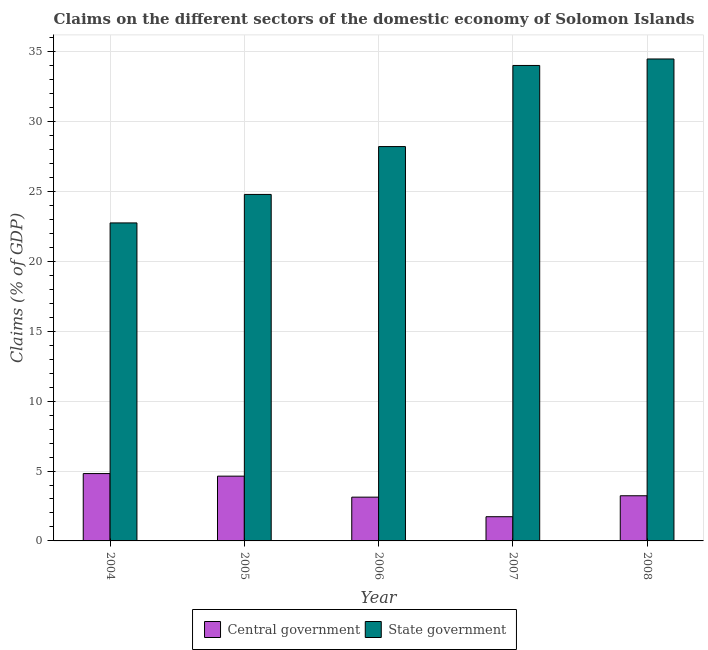Are the number of bars per tick equal to the number of legend labels?
Your answer should be compact. Yes. How many bars are there on the 5th tick from the right?
Ensure brevity in your answer.  2. What is the label of the 3rd group of bars from the left?
Offer a very short reply. 2006. What is the claims on central government in 2004?
Your answer should be compact. 4.82. Across all years, what is the maximum claims on state government?
Your answer should be compact. 34.48. Across all years, what is the minimum claims on central government?
Your response must be concise. 1.73. In which year was the claims on state government maximum?
Your response must be concise. 2008. In which year was the claims on central government minimum?
Offer a terse response. 2007. What is the total claims on central government in the graph?
Your response must be concise. 17.54. What is the difference between the claims on state government in 2006 and that in 2007?
Keep it short and to the point. -5.8. What is the difference between the claims on state government in 2005 and the claims on central government in 2004?
Provide a short and direct response. 2.04. What is the average claims on central government per year?
Offer a terse response. 3.51. In the year 2005, what is the difference between the claims on central government and claims on state government?
Give a very brief answer. 0. In how many years, is the claims on state government greater than 23 %?
Offer a terse response. 4. What is the ratio of the claims on state government in 2004 to that in 2005?
Make the answer very short. 0.92. What is the difference between the highest and the second highest claims on state government?
Ensure brevity in your answer.  0.46. What is the difference between the highest and the lowest claims on state government?
Your response must be concise. 11.73. What does the 2nd bar from the left in 2008 represents?
Keep it short and to the point. State government. What does the 2nd bar from the right in 2008 represents?
Make the answer very short. Central government. What is the difference between two consecutive major ticks on the Y-axis?
Your response must be concise. 5. Are the values on the major ticks of Y-axis written in scientific E-notation?
Your answer should be very brief. No. Does the graph contain grids?
Your answer should be compact. Yes. Where does the legend appear in the graph?
Give a very brief answer. Bottom center. How many legend labels are there?
Provide a succinct answer. 2. How are the legend labels stacked?
Provide a succinct answer. Horizontal. What is the title of the graph?
Your response must be concise. Claims on the different sectors of the domestic economy of Solomon Islands. Does "Nitrous oxide" appear as one of the legend labels in the graph?
Give a very brief answer. No. What is the label or title of the X-axis?
Your answer should be compact. Year. What is the label or title of the Y-axis?
Your answer should be compact. Claims (% of GDP). What is the Claims (% of GDP) of Central government in 2004?
Offer a terse response. 4.82. What is the Claims (% of GDP) of State government in 2004?
Give a very brief answer. 22.75. What is the Claims (% of GDP) of Central government in 2005?
Keep it short and to the point. 4.63. What is the Claims (% of GDP) in State government in 2005?
Your answer should be compact. 24.79. What is the Claims (% of GDP) in Central government in 2006?
Ensure brevity in your answer.  3.13. What is the Claims (% of GDP) in State government in 2006?
Keep it short and to the point. 28.21. What is the Claims (% of GDP) in Central government in 2007?
Your response must be concise. 1.73. What is the Claims (% of GDP) in State government in 2007?
Ensure brevity in your answer.  34.01. What is the Claims (% of GDP) of Central government in 2008?
Your answer should be compact. 3.23. What is the Claims (% of GDP) of State government in 2008?
Your answer should be compact. 34.48. Across all years, what is the maximum Claims (% of GDP) in Central government?
Offer a terse response. 4.82. Across all years, what is the maximum Claims (% of GDP) in State government?
Your answer should be compact. 34.48. Across all years, what is the minimum Claims (% of GDP) in Central government?
Provide a succinct answer. 1.73. Across all years, what is the minimum Claims (% of GDP) in State government?
Keep it short and to the point. 22.75. What is the total Claims (% of GDP) of Central government in the graph?
Your answer should be very brief. 17.54. What is the total Claims (% of GDP) of State government in the graph?
Ensure brevity in your answer.  144.24. What is the difference between the Claims (% of GDP) of Central government in 2004 and that in 2005?
Your response must be concise. 0.18. What is the difference between the Claims (% of GDP) in State government in 2004 and that in 2005?
Offer a very short reply. -2.04. What is the difference between the Claims (% of GDP) of Central government in 2004 and that in 2006?
Offer a terse response. 1.69. What is the difference between the Claims (% of GDP) in State government in 2004 and that in 2006?
Your answer should be compact. -5.46. What is the difference between the Claims (% of GDP) of Central government in 2004 and that in 2007?
Offer a terse response. 3.09. What is the difference between the Claims (% of GDP) in State government in 2004 and that in 2007?
Provide a short and direct response. -11.26. What is the difference between the Claims (% of GDP) of Central government in 2004 and that in 2008?
Provide a succinct answer. 1.59. What is the difference between the Claims (% of GDP) in State government in 2004 and that in 2008?
Your response must be concise. -11.73. What is the difference between the Claims (% of GDP) in Central government in 2005 and that in 2006?
Make the answer very short. 1.5. What is the difference between the Claims (% of GDP) of State government in 2005 and that in 2006?
Offer a terse response. -3.42. What is the difference between the Claims (% of GDP) in Central government in 2005 and that in 2007?
Ensure brevity in your answer.  2.9. What is the difference between the Claims (% of GDP) in State government in 2005 and that in 2007?
Your answer should be compact. -9.23. What is the difference between the Claims (% of GDP) in Central government in 2005 and that in 2008?
Provide a short and direct response. 1.4. What is the difference between the Claims (% of GDP) in State government in 2005 and that in 2008?
Provide a short and direct response. -9.69. What is the difference between the Claims (% of GDP) of Central government in 2006 and that in 2007?
Ensure brevity in your answer.  1.4. What is the difference between the Claims (% of GDP) of State government in 2006 and that in 2007?
Offer a very short reply. -5.8. What is the difference between the Claims (% of GDP) of Central government in 2006 and that in 2008?
Give a very brief answer. -0.1. What is the difference between the Claims (% of GDP) of State government in 2006 and that in 2008?
Offer a very short reply. -6.27. What is the difference between the Claims (% of GDP) in Central government in 2007 and that in 2008?
Provide a succinct answer. -1.5. What is the difference between the Claims (% of GDP) of State government in 2007 and that in 2008?
Your answer should be very brief. -0.46. What is the difference between the Claims (% of GDP) of Central government in 2004 and the Claims (% of GDP) of State government in 2005?
Offer a very short reply. -19.97. What is the difference between the Claims (% of GDP) of Central government in 2004 and the Claims (% of GDP) of State government in 2006?
Offer a terse response. -23.39. What is the difference between the Claims (% of GDP) in Central government in 2004 and the Claims (% of GDP) in State government in 2007?
Keep it short and to the point. -29.2. What is the difference between the Claims (% of GDP) of Central government in 2004 and the Claims (% of GDP) of State government in 2008?
Ensure brevity in your answer.  -29.66. What is the difference between the Claims (% of GDP) of Central government in 2005 and the Claims (% of GDP) of State government in 2006?
Your response must be concise. -23.58. What is the difference between the Claims (% of GDP) in Central government in 2005 and the Claims (% of GDP) in State government in 2007?
Your answer should be compact. -29.38. What is the difference between the Claims (% of GDP) in Central government in 2005 and the Claims (% of GDP) in State government in 2008?
Keep it short and to the point. -29.84. What is the difference between the Claims (% of GDP) in Central government in 2006 and the Claims (% of GDP) in State government in 2007?
Offer a very short reply. -30.88. What is the difference between the Claims (% of GDP) in Central government in 2006 and the Claims (% of GDP) in State government in 2008?
Your answer should be compact. -31.35. What is the difference between the Claims (% of GDP) of Central government in 2007 and the Claims (% of GDP) of State government in 2008?
Give a very brief answer. -32.75. What is the average Claims (% of GDP) in Central government per year?
Offer a terse response. 3.51. What is the average Claims (% of GDP) in State government per year?
Offer a terse response. 28.85. In the year 2004, what is the difference between the Claims (% of GDP) of Central government and Claims (% of GDP) of State government?
Give a very brief answer. -17.93. In the year 2005, what is the difference between the Claims (% of GDP) in Central government and Claims (% of GDP) in State government?
Provide a succinct answer. -20.15. In the year 2006, what is the difference between the Claims (% of GDP) of Central government and Claims (% of GDP) of State government?
Provide a short and direct response. -25.08. In the year 2007, what is the difference between the Claims (% of GDP) of Central government and Claims (% of GDP) of State government?
Offer a very short reply. -32.28. In the year 2008, what is the difference between the Claims (% of GDP) of Central government and Claims (% of GDP) of State government?
Your response must be concise. -31.25. What is the ratio of the Claims (% of GDP) of Central government in 2004 to that in 2005?
Offer a terse response. 1.04. What is the ratio of the Claims (% of GDP) in State government in 2004 to that in 2005?
Offer a terse response. 0.92. What is the ratio of the Claims (% of GDP) in Central government in 2004 to that in 2006?
Your answer should be very brief. 1.54. What is the ratio of the Claims (% of GDP) in State government in 2004 to that in 2006?
Ensure brevity in your answer.  0.81. What is the ratio of the Claims (% of GDP) of Central government in 2004 to that in 2007?
Offer a terse response. 2.78. What is the ratio of the Claims (% of GDP) of State government in 2004 to that in 2007?
Your response must be concise. 0.67. What is the ratio of the Claims (% of GDP) of Central government in 2004 to that in 2008?
Provide a short and direct response. 1.49. What is the ratio of the Claims (% of GDP) in State government in 2004 to that in 2008?
Keep it short and to the point. 0.66. What is the ratio of the Claims (% of GDP) of Central government in 2005 to that in 2006?
Keep it short and to the point. 1.48. What is the ratio of the Claims (% of GDP) in State government in 2005 to that in 2006?
Your answer should be very brief. 0.88. What is the ratio of the Claims (% of GDP) in Central government in 2005 to that in 2007?
Your response must be concise. 2.67. What is the ratio of the Claims (% of GDP) in State government in 2005 to that in 2007?
Your answer should be compact. 0.73. What is the ratio of the Claims (% of GDP) in Central government in 2005 to that in 2008?
Offer a very short reply. 1.43. What is the ratio of the Claims (% of GDP) in State government in 2005 to that in 2008?
Provide a short and direct response. 0.72. What is the ratio of the Claims (% of GDP) of Central government in 2006 to that in 2007?
Ensure brevity in your answer.  1.81. What is the ratio of the Claims (% of GDP) in State government in 2006 to that in 2007?
Make the answer very short. 0.83. What is the ratio of the Claims (% of GDP) in Central government in 2006 to that in 2008?
Ensure brevity in your answer.  0.97. What is the ratio of the Claims (% of GDP) of State government in 2006 to that in 2008?
Ensure brevity in your answer.  0.82. What is the ratio of the Claims (% of GDP) of Central government in 2007 to that in 2008?
Your answer should be very brief. 0.54. What is the ratio of the Claims (% of GDP) of State government in 2007 to that in 2008?
Your answer should be compact. 0.99. What is the difference between the highest and the second highest Claims (% of GDP) in Central government?
Your answer should be compact. 0.18. What is the difference between the highest and the second highest Claims (% of GDP) in State government?
Your answer should be very brief. 0.46. What is the difference between the highest and the lowest Claims (% of GDP) in Central government?
Keep it short and to the point. 3.09. What is the difference between the highest and the lowest Claims (% of GDP) in State government?
Give a very brief answer. 11.73. 